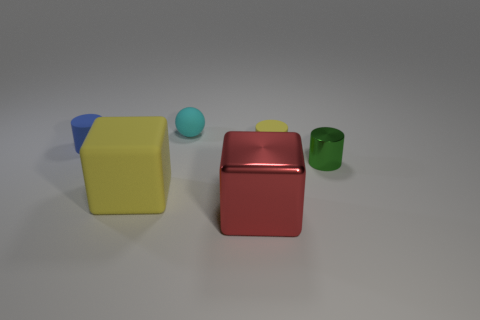Add 3 large cubes. How many objects exist? 9 Subtract all blocks. How many objects are left? 4 Subtract all big red shiny things. Subtract all small yellow things. How many objects are left? 4 Add 6 small objects. How many small objects are left? 10 Add 6 metallic cylinders. How many metallic cylinders exist? 7 Subtract 0 gray blocks. How many objects are left? 6 